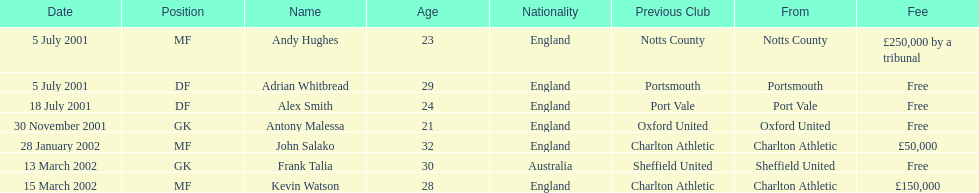Whos name is listed last on the chart? Kevin Watson. 